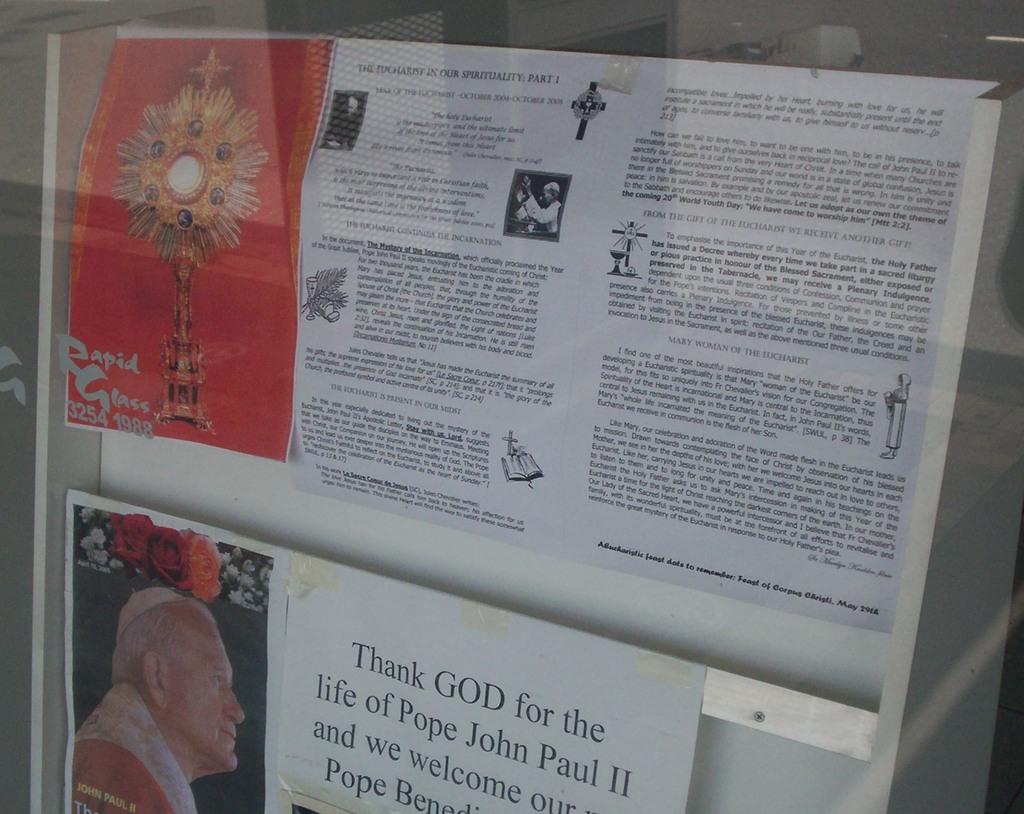Please provide a concise description of this image. In this image I can see few papers attached to the white colored boards and on the papers I can see few picture of persons and something is written. I can see the glass in front of the board. 